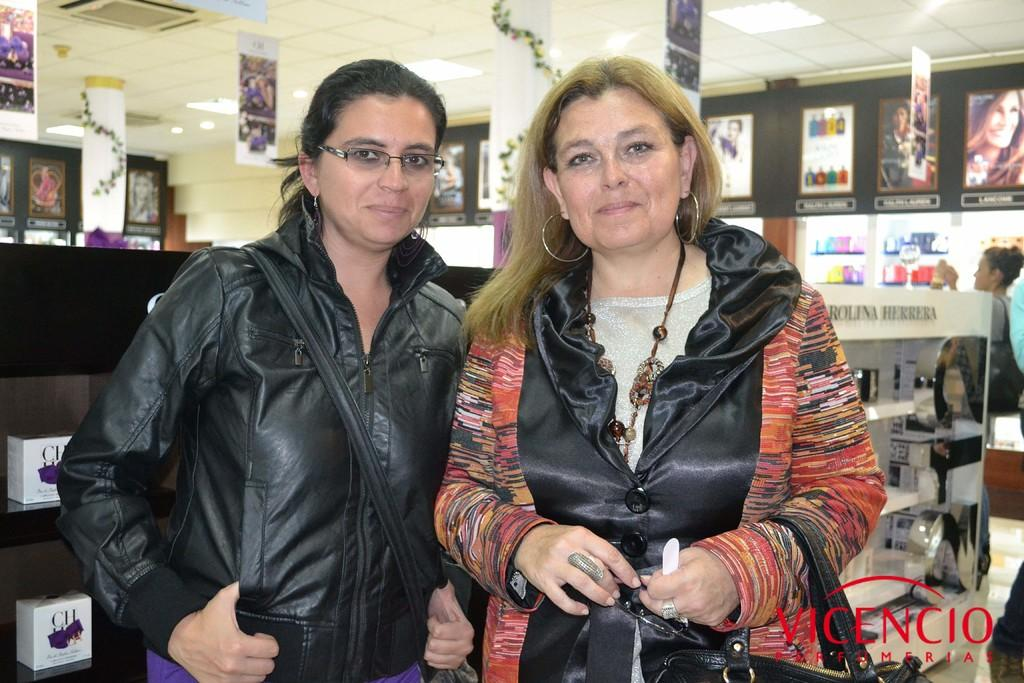What is the position of the woman wearing a black coat in the image? The woman wearing a black coat is standing on the left side of the image. What is the woman on the right side of the image doing? The woman on the right side of the image is smiling. Can you describe the clothing of the woman on the left side of the image? The woman on the left side of the image is wearing a black coat. What type of liquid is the bird teaching in the image? There is no bird or liquid present in the image. The image features two women, one of whom is wearing a black coat and standing on the left side, while the other is smiling on the right side. 